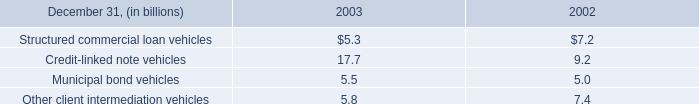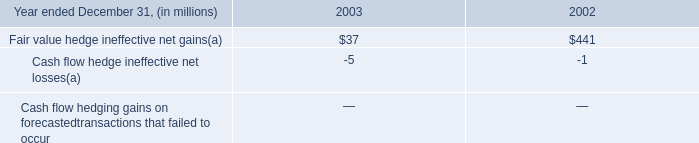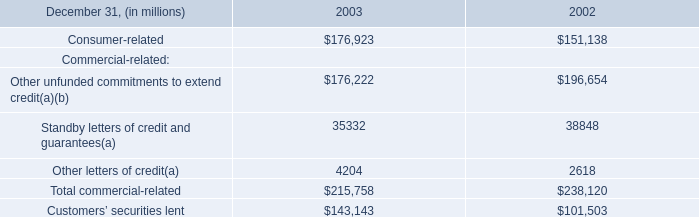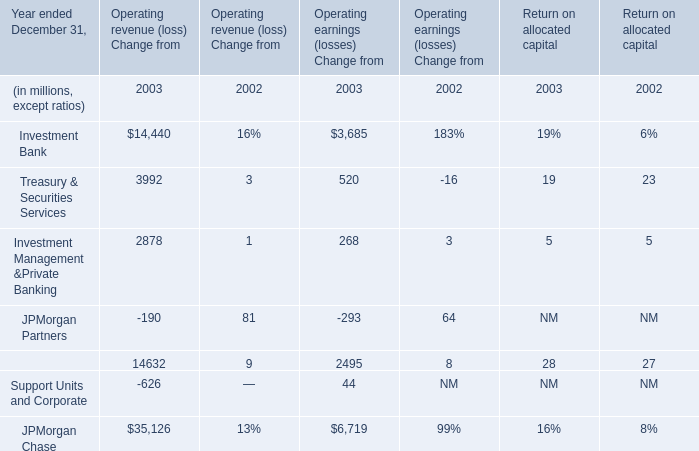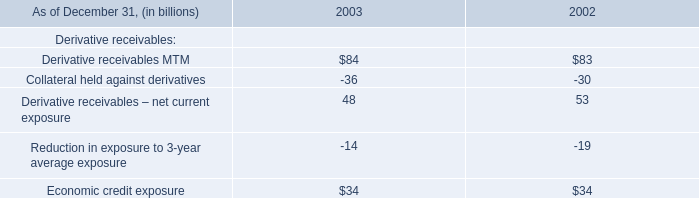What is the average amount of Operating revenue (loss) Change from Treasury & Securities Services and Chase Financial Services in 2003? (in million) 
Computations: ((3992 + 14632) / 2)
Answer: 9312.0. 